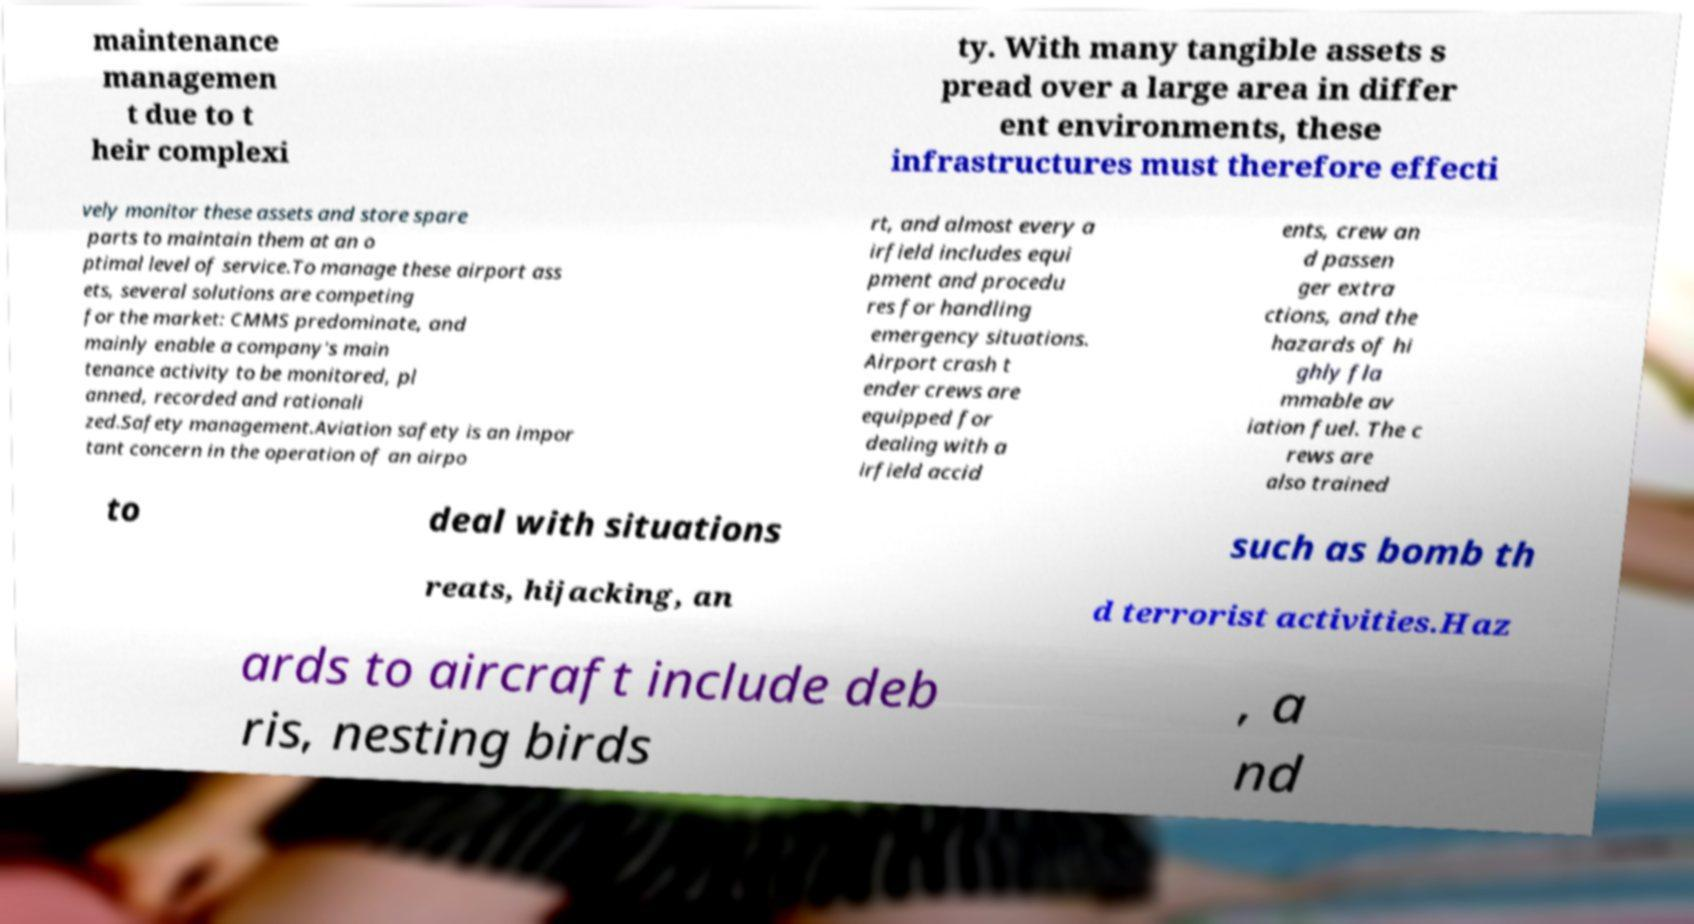Could you assist in decoding the text presented in this image and type it out clearly? maintenance managemen t due to t heir complexi ty. With many tangible assets s pread over a large area in differ ent environments, these infrastructures must therefore effecti vely monitor these assets and store spare parts to maintain them at an o ptimal level of service.To manage these airport ass ets, several solutions are competing for the market: CMMS predominate, and mainly enable a company's main tenance activity to be monitored, pl anned, recorded and rationali zed.Safety management.Aviation safety is an impor tant concern in the operation of an airpo rt, and almost every a irfield includes equi pment and procedu res for handling emergency situations. Airport crash t ender crews are equipped for dealing with a irfield accid ents, crew an d passen ger extra ctions, and the hazards of hi ghly fla mmable av iation fuel. The c rews are also trained to deal with situations such as bomb th reats, hijacking, an d terrorist activities.Haz ards to aircraft include deb ris, nesting birds , a nd 